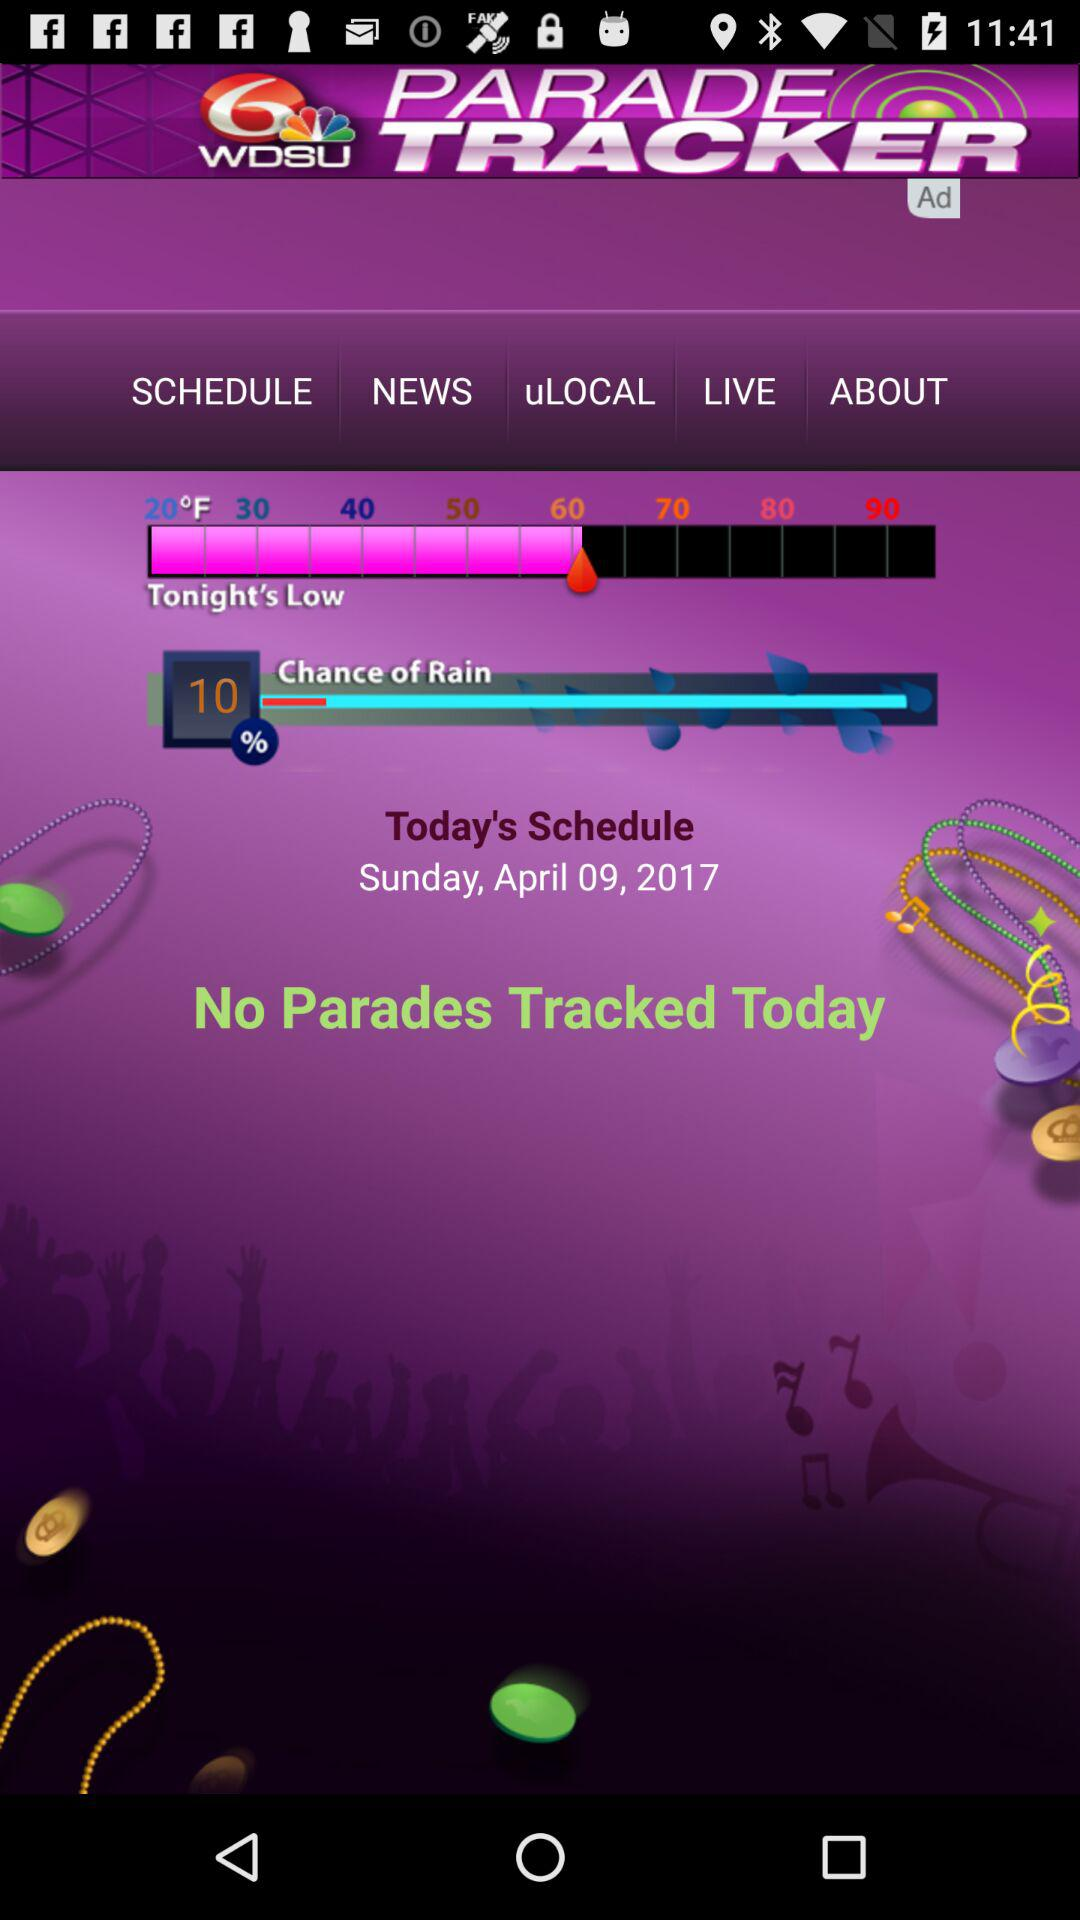What is the scheduled date? The scheduled date is Sunday, April 09, 2017. 